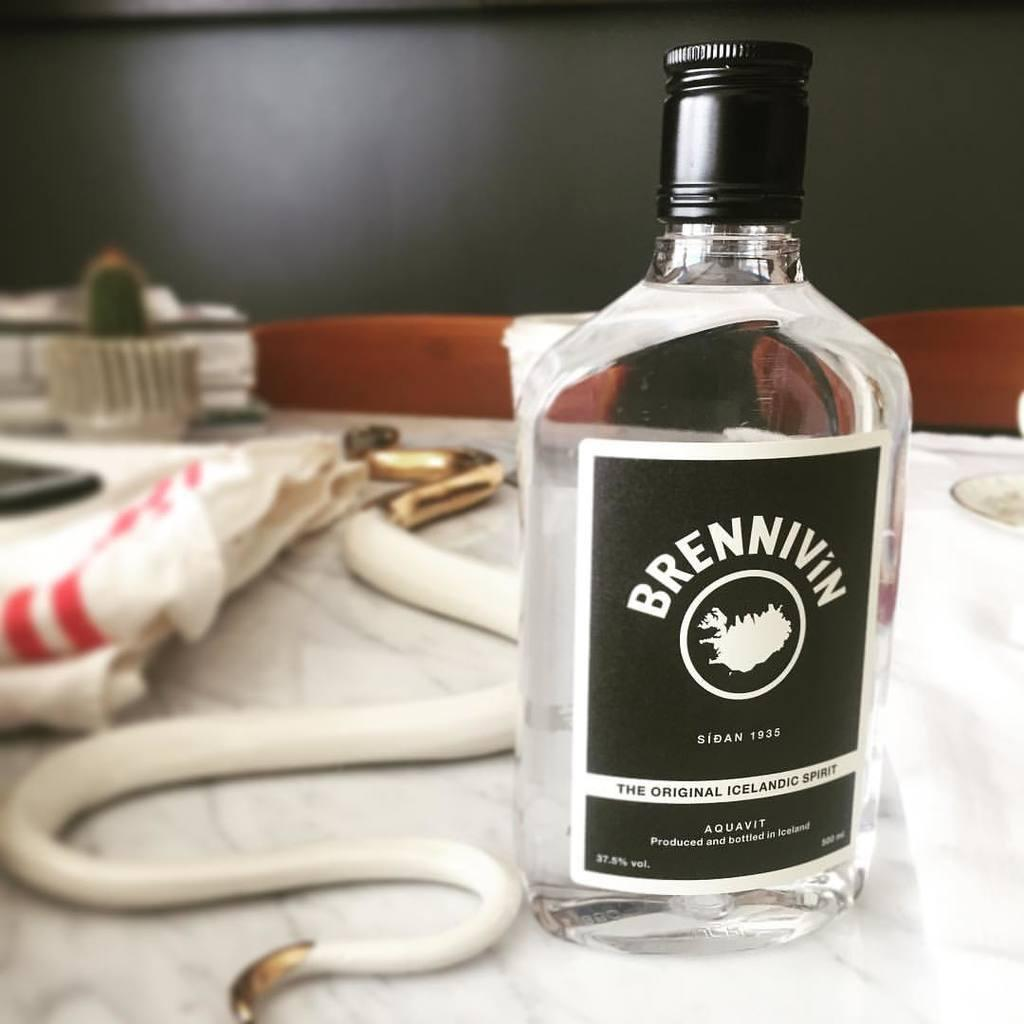What object can be seen in the image? There is a bottle in the image. How many passengers are visible in the image? There are no passengers present in the image, as it only features a bottle. What type of work is being done in the image? There is no work being done in the image, as it only features a bottle. 